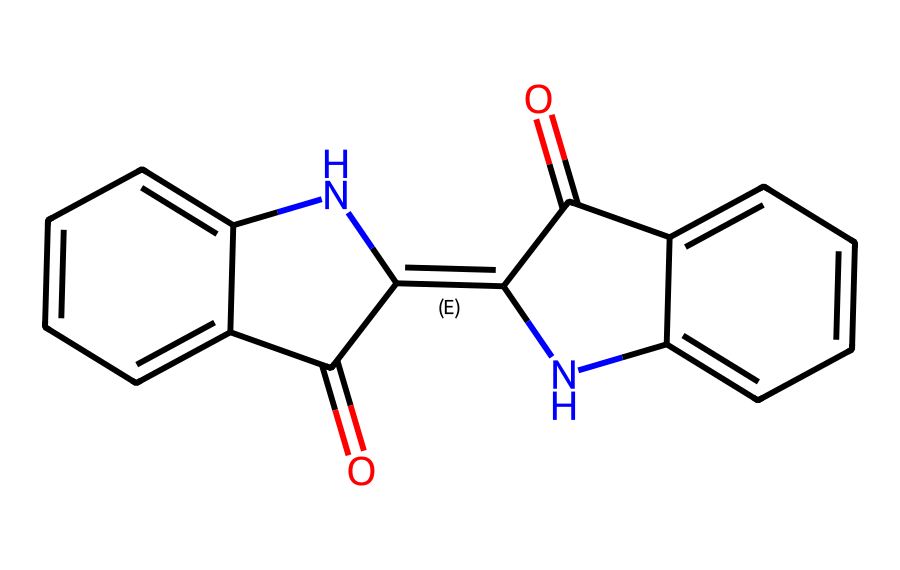what is the molecular formula of this compound? By analyzing the SMILES representation, we can count the atoms: there are 15 carbon (C) atoms, 10 hydrogen (H) atoms, 2 nitrogen (N) atoms, and 2 oxygen (O) atoms. Combining these gives us the molecular formula C15H10N2O2.
Answer: C15H10N2O2 how many rings are present in the structure? The SMILES representation indicates that there are multiple connection points creating cyclic structures. Upon reviewing, we can identify two distinct rings within the chemical structure.
Answer: 2 which atoms are responsible for the dyeing properties of this molecule? The presence of the nitrogen and oxygen atoms suggests that they contribute to the dyeing properties. Specifically, the conjugated system formed by the alternating double bonds enhances light absorption, which is essential for dyeing.
Answer: nitrogen and oxygen what type of chemical structure is characterized by this molecule? This molecule contains nitrogen atoms in a ring structure and is derived from plant sources, fitting the definition of an alkaloid. Alkaloids are known for their complex structures and biological activity.
Answer: alkaloid how does the structure relate to its application in textiles? The double bonds in the structure allow for delocalization of electrons, which is crucial for the absorption of light and thus the coloration of fabrics. The unique structure enables alizarin to produce deep, rich colors when applied to textiles.
Answer: electron delocalization what is the significance of the nitrogen atoms in indigo's structure? The nitrogen atoms contribute to the basicity and possible reactivity of the compound, influencing its behavior when used as a dye. In dyeing, these properties can affect how well the dye bonds with the fibers of textiles.
Answer: reactivity which part of the structure contributes to its color? The system of alternating double bonds (conjugated system) present in the structure allows the molecule to absorb specific wavelengths of light, resulting in its characteristic blue color.
Answer: conjugated system 